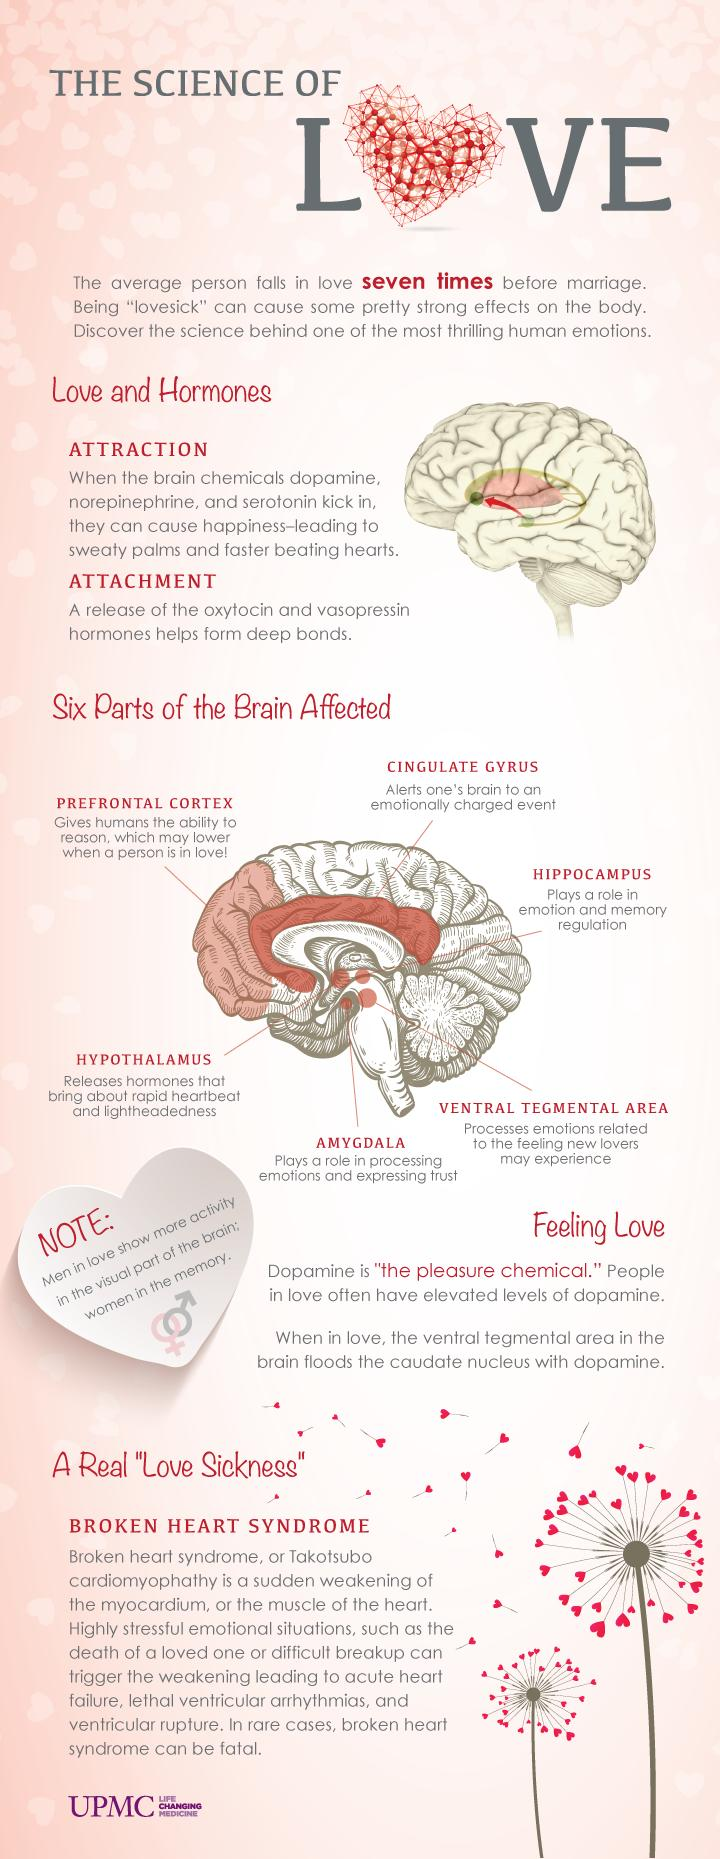Point out several critical features in this image. There are two points under the heading "Love and Hormones". The ventral tegmental area of the brain is responsible for processing emotions related to the feeling of new lovers. The amygdala is the part of the brain that plays a crucial role in processing emotions and expressing trust. Under the heading "Love and Hormones," the concepts of attraction and attachment are discussed. 